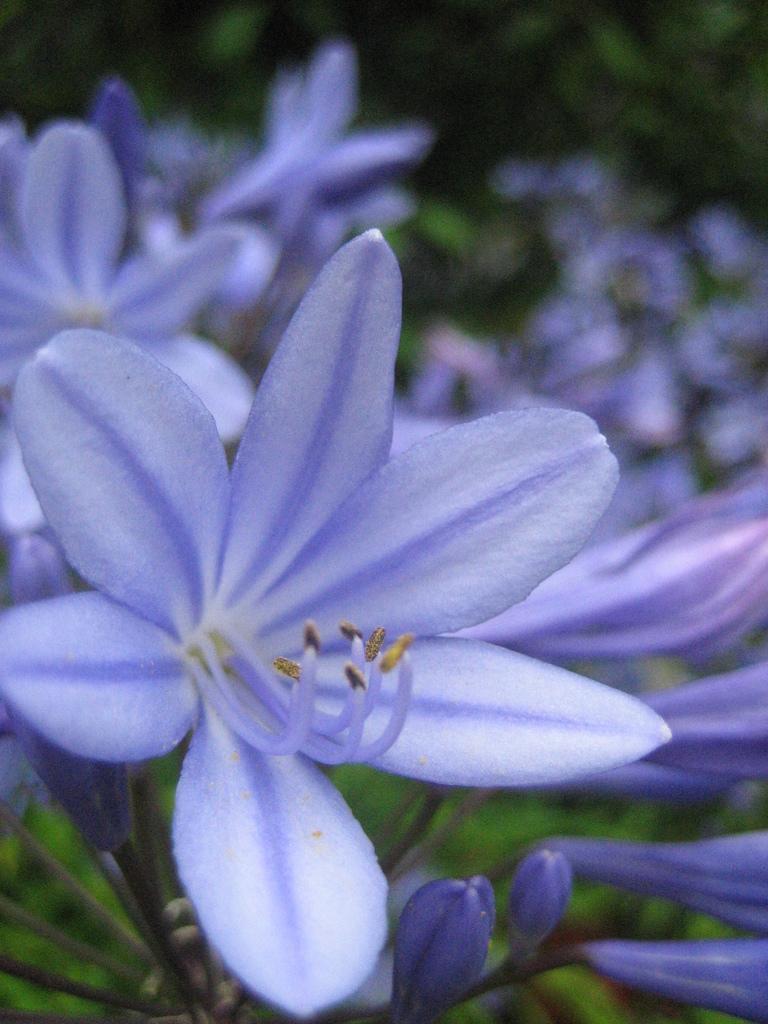Could you give a brief overview of what you see in this image? Here we can see flowers and buds. There is a blur background with greenery. 